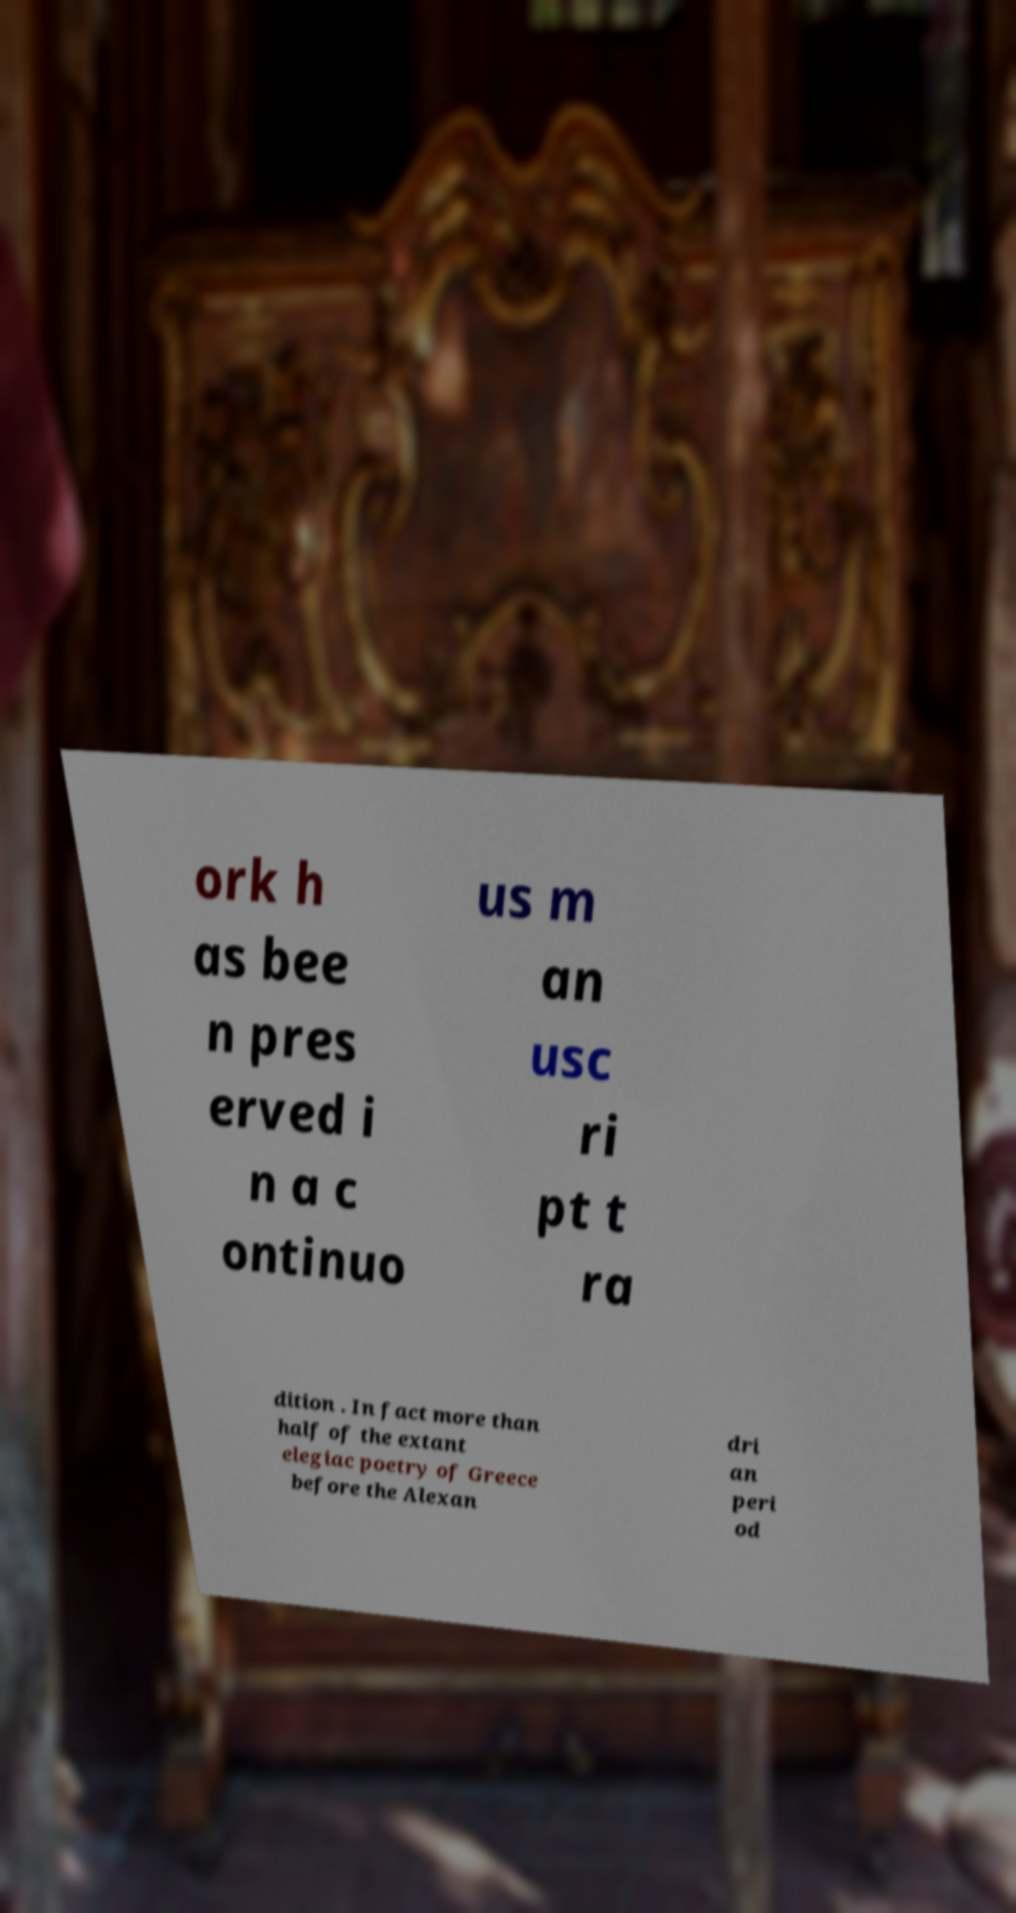Please identify and transcribe the text found in this image. ork h as bee n pres erved i n a c ontinuo us m an usc ri pt t ra dition . In fact more than half of the extant elegiac poetry of Greece before the Alexan dri an peri od 